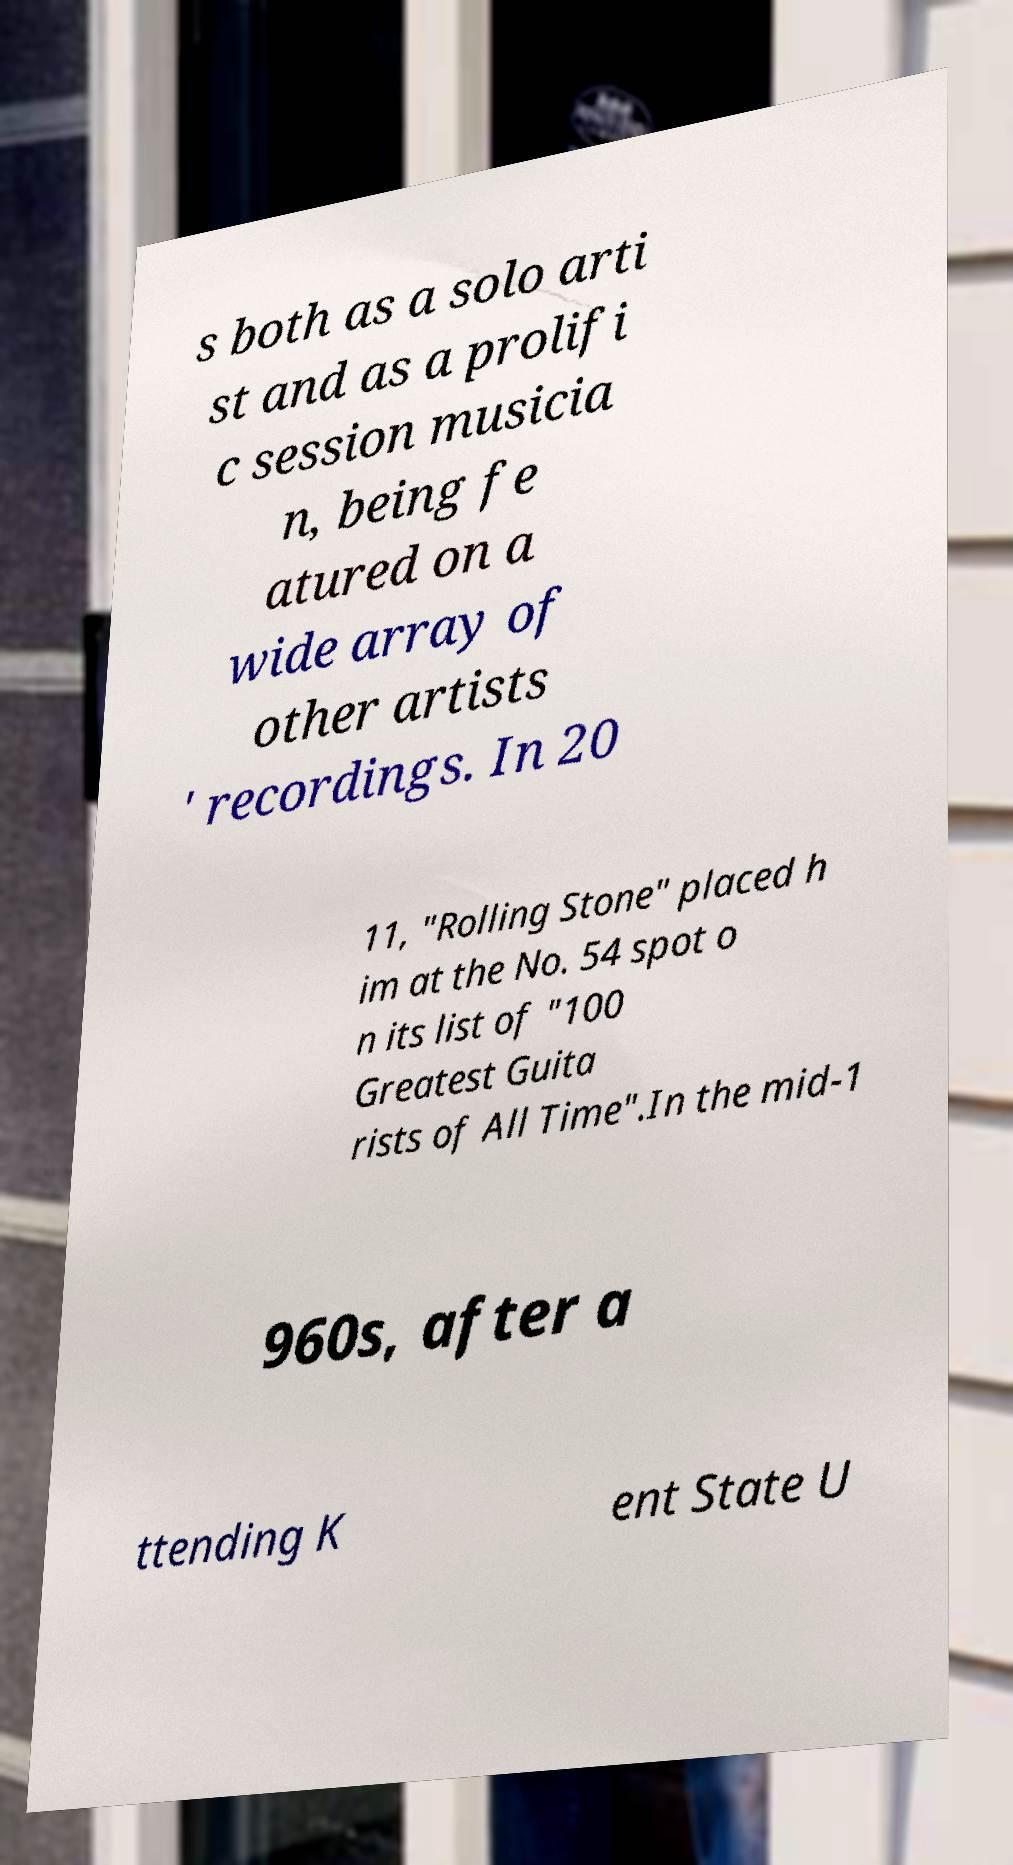There's text embedded in this image that I need extracted. Can you transcribe it verbatim? s both as a solo arti st and as a prolifi c session musicia n, being fe atured on a wide array of other artists ' recordings. In 20 11, "Rolling Stone" placed h im at the No. 54 spot o n its list of "100 Greatest Guita rists of All Time".In the mid-1 960s, after a ttending K ent State U 